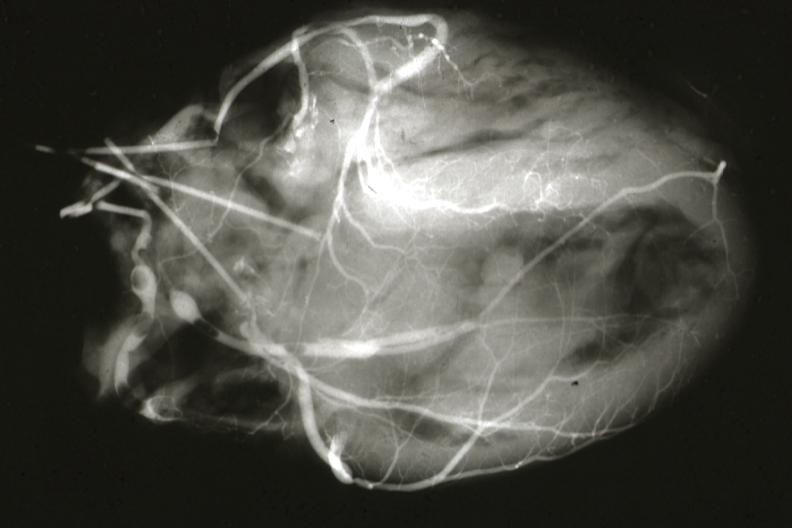does this image show postmortangiogram of coronary arteries?
Answer the question using a single word or phrase. Yes 